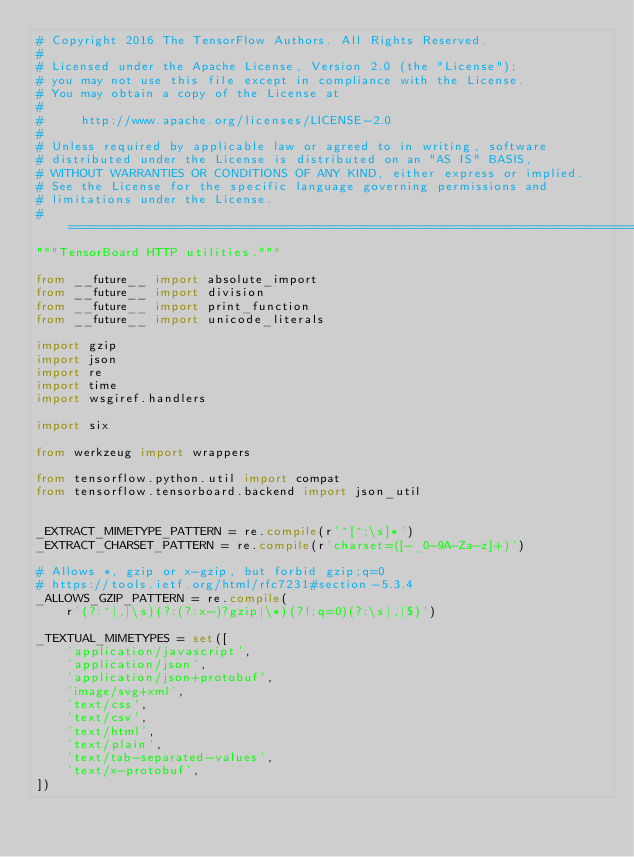<code> <loc_0><loc_0><loc_500><loc_500><_Python_># Copyright 2016 The TensorFlow Authors. All Rights Reserved.
#
# Licensed under the Apache License, Version 2.0 (the "License");
# you may not use this file except in compliance with the License.
# You may obtain a copy of the License at
#
#     http://www.apache.org/licenses/LICENSE-2.0
#
# Unless required by applicable law or agreed to in writing, software
# distributed under the License is distributed on an "AS IS" BASIS,
# WITHOUT WARRANTIES OR CONDITIONS OF ANY KIND, either express or implied.
# See the License for the specific language governing permissions and
# limitations under the License.
# ==============================================================================
"""TensorBoard HTTP utilities."""

from __future__ import absolute_import
from __future__ import division
from __future__ import print_function
from __future__ import unicode_literals

import gzip
import json
import re
import time
import wsgiref.handlers

import six

from werkzeug import wrappers

from tensorflow.python.util import compat
from tensorflow.tensorboard.backend import json_util


_EXTRACT_MIMETYPE_PATTERN = re.compile(r'^[^;\s]*')
_EXTRACT_CHARSET_PATTERN = re.compile(r'charset=([-_0-9A-Za-z]+)')

# Allows *, gzip or x-gzip, but forbid gzip;q=0
# https://tools.ietf.org/html/rfc7231#section-5.3.4
_ALLOWS_GZIP_PATTERN = re.compile(
    r'(?:^|,|\s)(?:(?:x-)?gzip|\*)(?!;q=0)(?:\s|,|$)')

_TEXTUAL_MIMETYPES = set([
    'application/javascript',
    'application/json',
    'application/json+protobuf',
    'image/svg+xml',
    'text/css',
    'text/csv',
    'text/html',
    'text/plain',
    'text/tab-separated-values',
    'text/x-protobuf',
])
</code> 